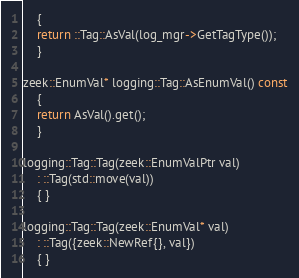Convert code to text. <code><loc_0><loc_0><loc_500><loc_500><_C++_>	{
	return ::Tag::AsVal(log_mgr->GetTagType());
	}

zeek::EnumVal* logging::Tag::AsEnumVal() const
	{
	return AsVal().get();
	}

logging::Tag::Tag(zeek::EnumValPtr val)
	: ::Tag(std::move(val))
	{ }

logging::Tag::Tag(zeek::EnumVal* val)
	: ::Tag({zeek::NewRef{}, val})
	{ }
</code> 